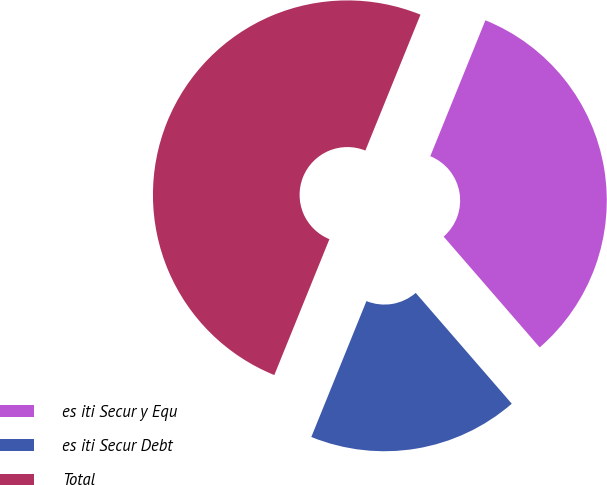Convert chart. <chart><loc_0><loc_0><loc_500><loc_500><pie_chart><fcel>es iti Secur y Equ<fcel>es iti Secur Debt<fcel>Total<nl><fcel>32.5%<fcel>17.5%<fcel>50.0%<nl></chart> 